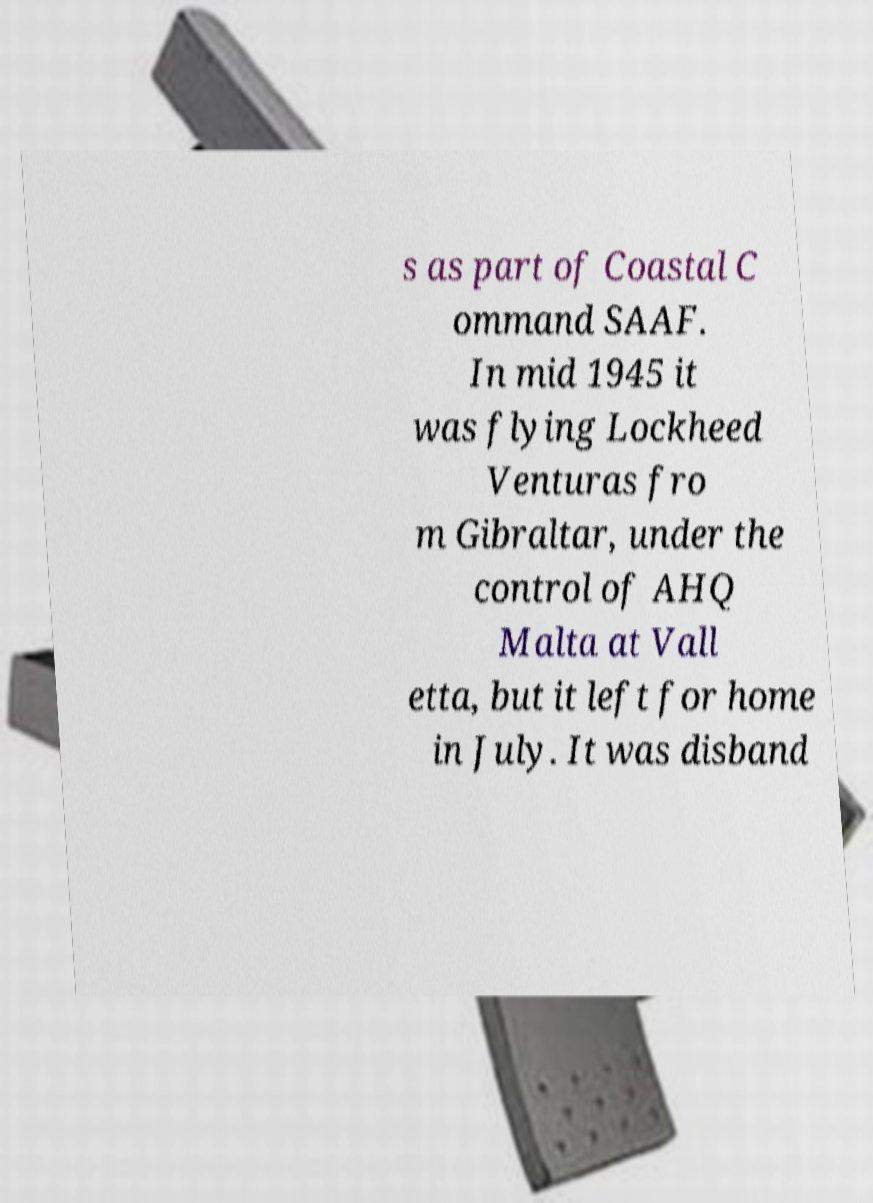Can you accurately transcribe the text from the provided image for me? s as part of Coastal C ommand SAAF. In mid 1945 it was flying Lockheed Venturas fro m Gibraltar, under the control of AHQ Malta at Vall etta, but it left for home in July. It was disband 